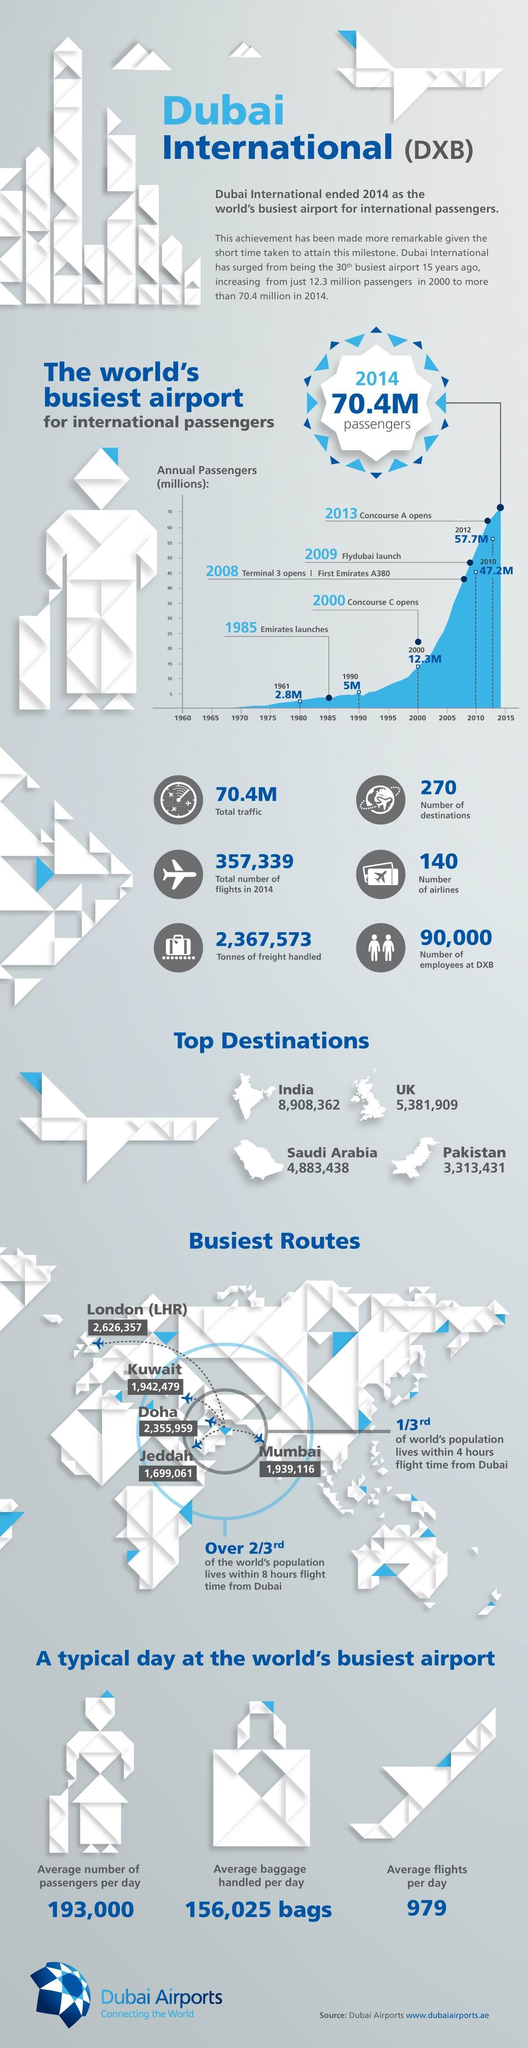Mention a couple of crucial points in this snapshot. In 2014, there were a total of 357,339 flights. The number of destinations is 270. There are 140 airlines currently operating in the world. The average number of passengers per day is 193,000. 